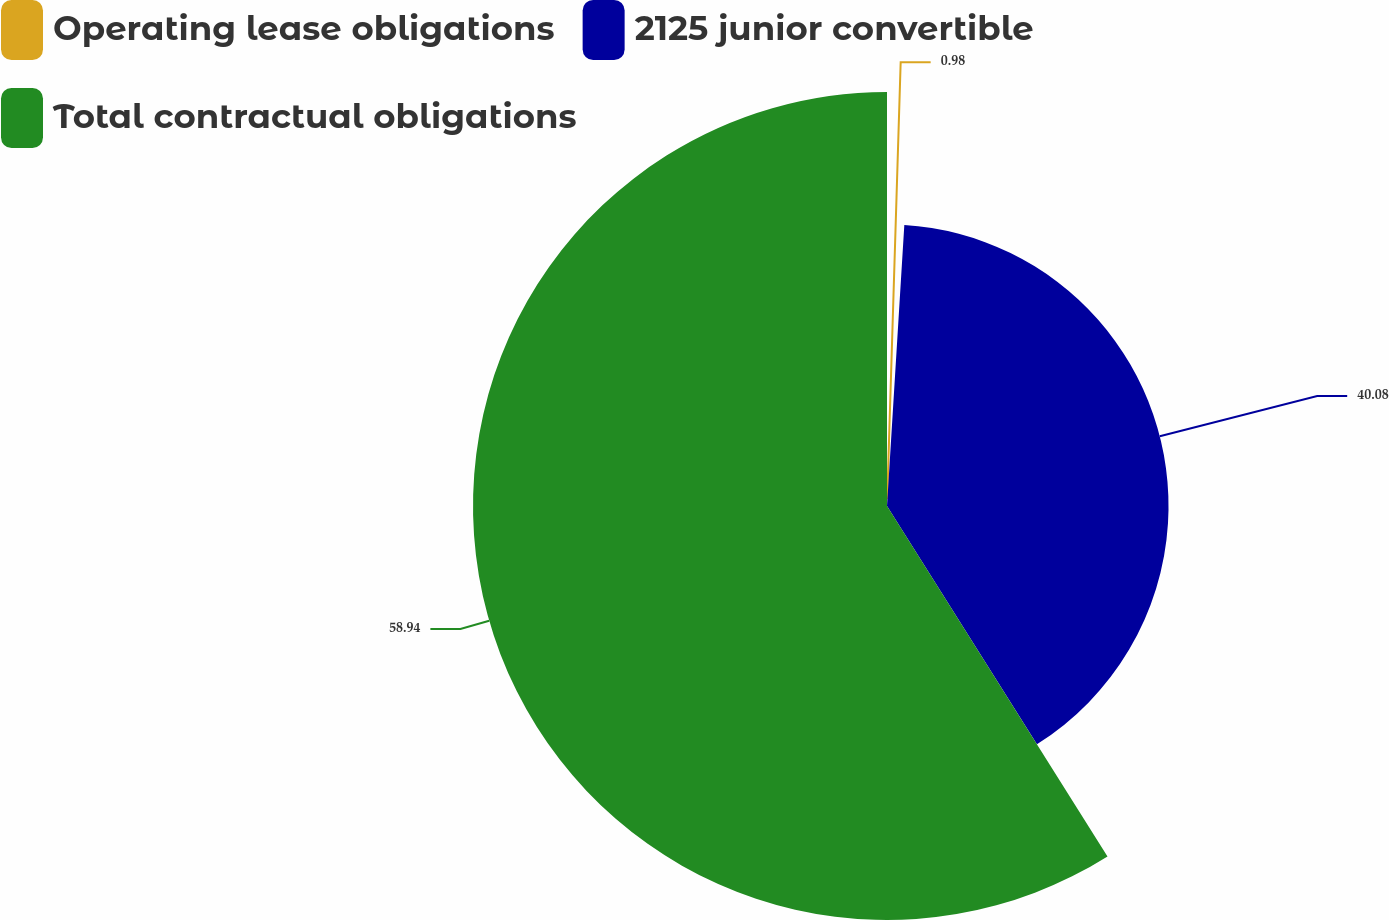Convert chart. <chart><loc_0><loc_0><loc_500><loc_500><pie_chart><fcel>Operating lease obligations<fcel>2125 junior convertible<fcel>Total contractual obligations<nl><fcel>0.98%<fcel>40.08%<fcel>58.94%<nl></chart> 